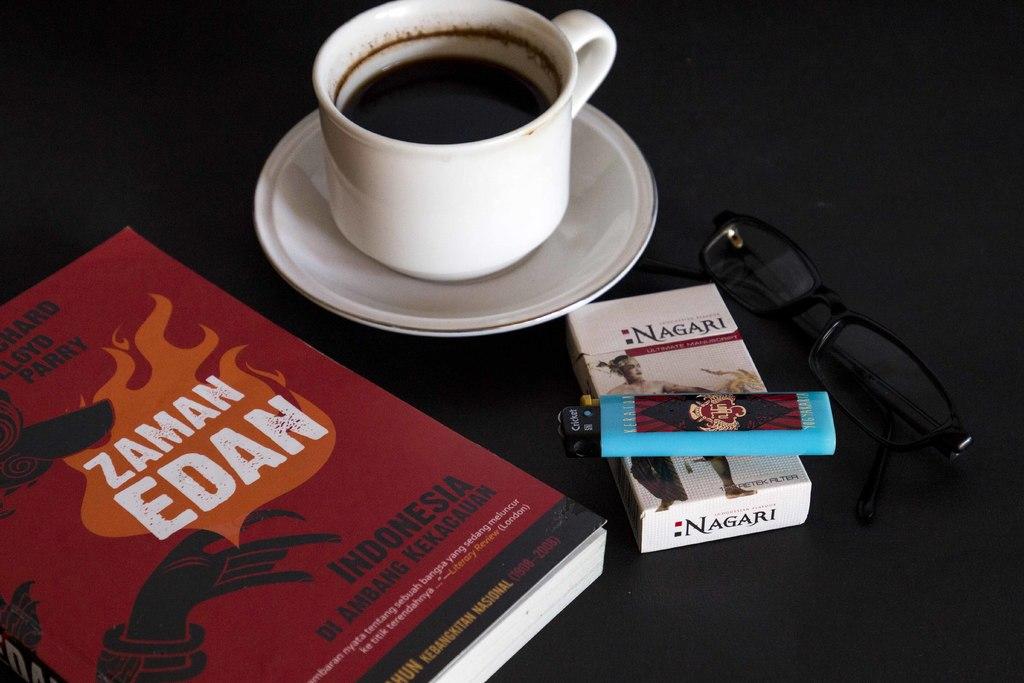What is the brand of the cigarettes?
Your answer should be compact. Nagari. Who wrote the book?
Your answer should be very brief. Zaman edan. 